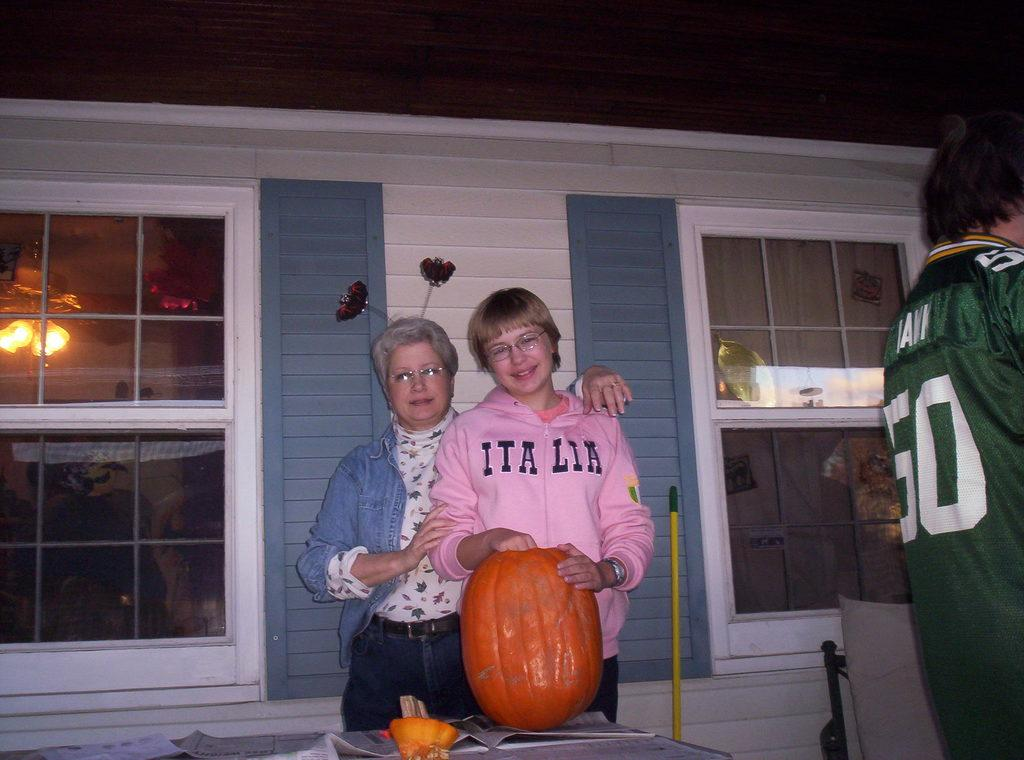<image>
Describe the image concisely. Girl wearing a pink hoodie that says Italia on it next to a pumpkin. 